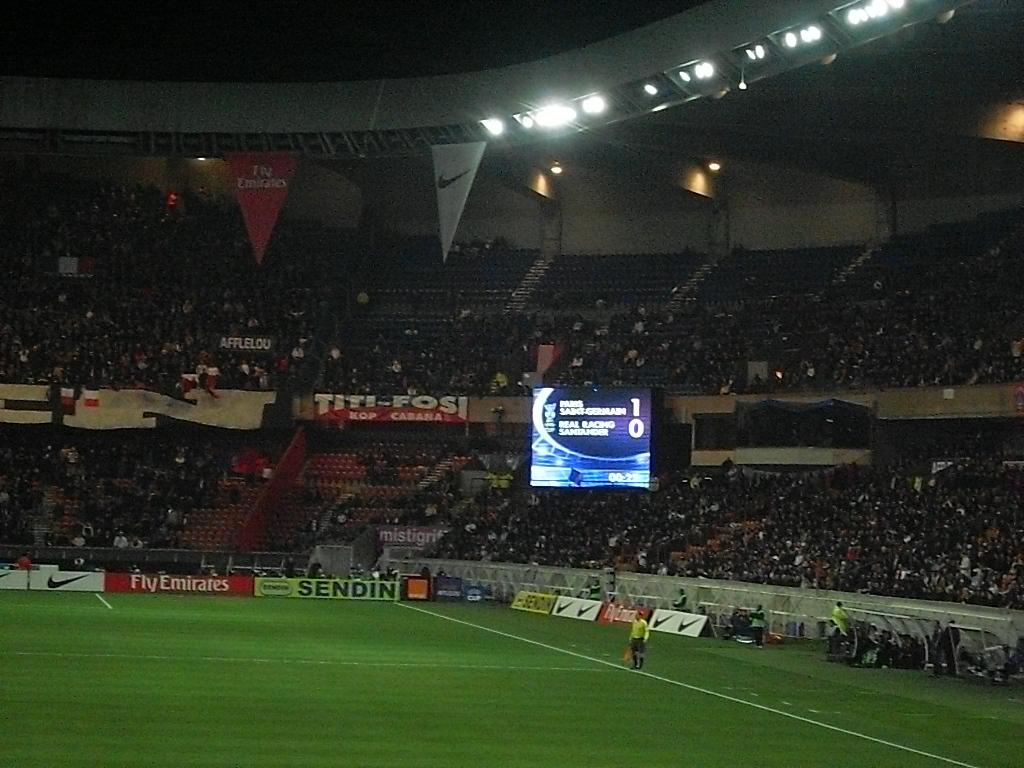Does fly emirates advertise here?
Your response must be concise. Yes. 